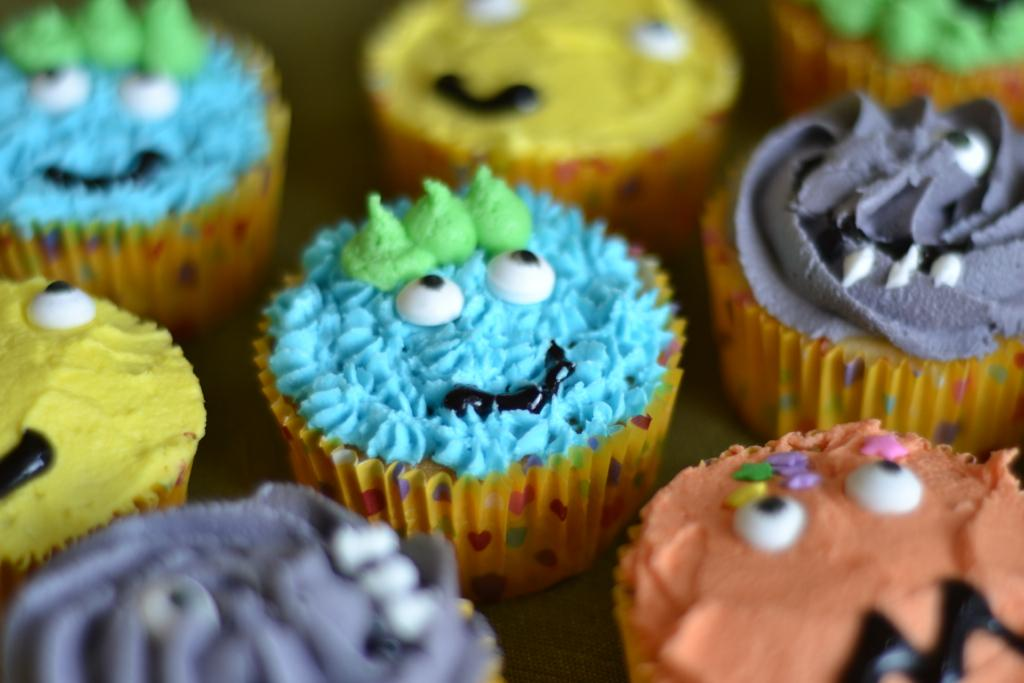What type of dessert can be seen in the image? There are cupcakes in the image. What is on top of the cupcakes? The cupcakes have cream on them. Are the cupcakes and creams in the same color? No, the cupcakes and creams are in different colors. What type of fruit can be seen in the image? There is no fruit present in the image; it features cupcakes with cream on them. Can you tell me how many cars are parked next to the cupcakes in the image? There are no cars present in the image; it only features cupcakes with cream on them. 